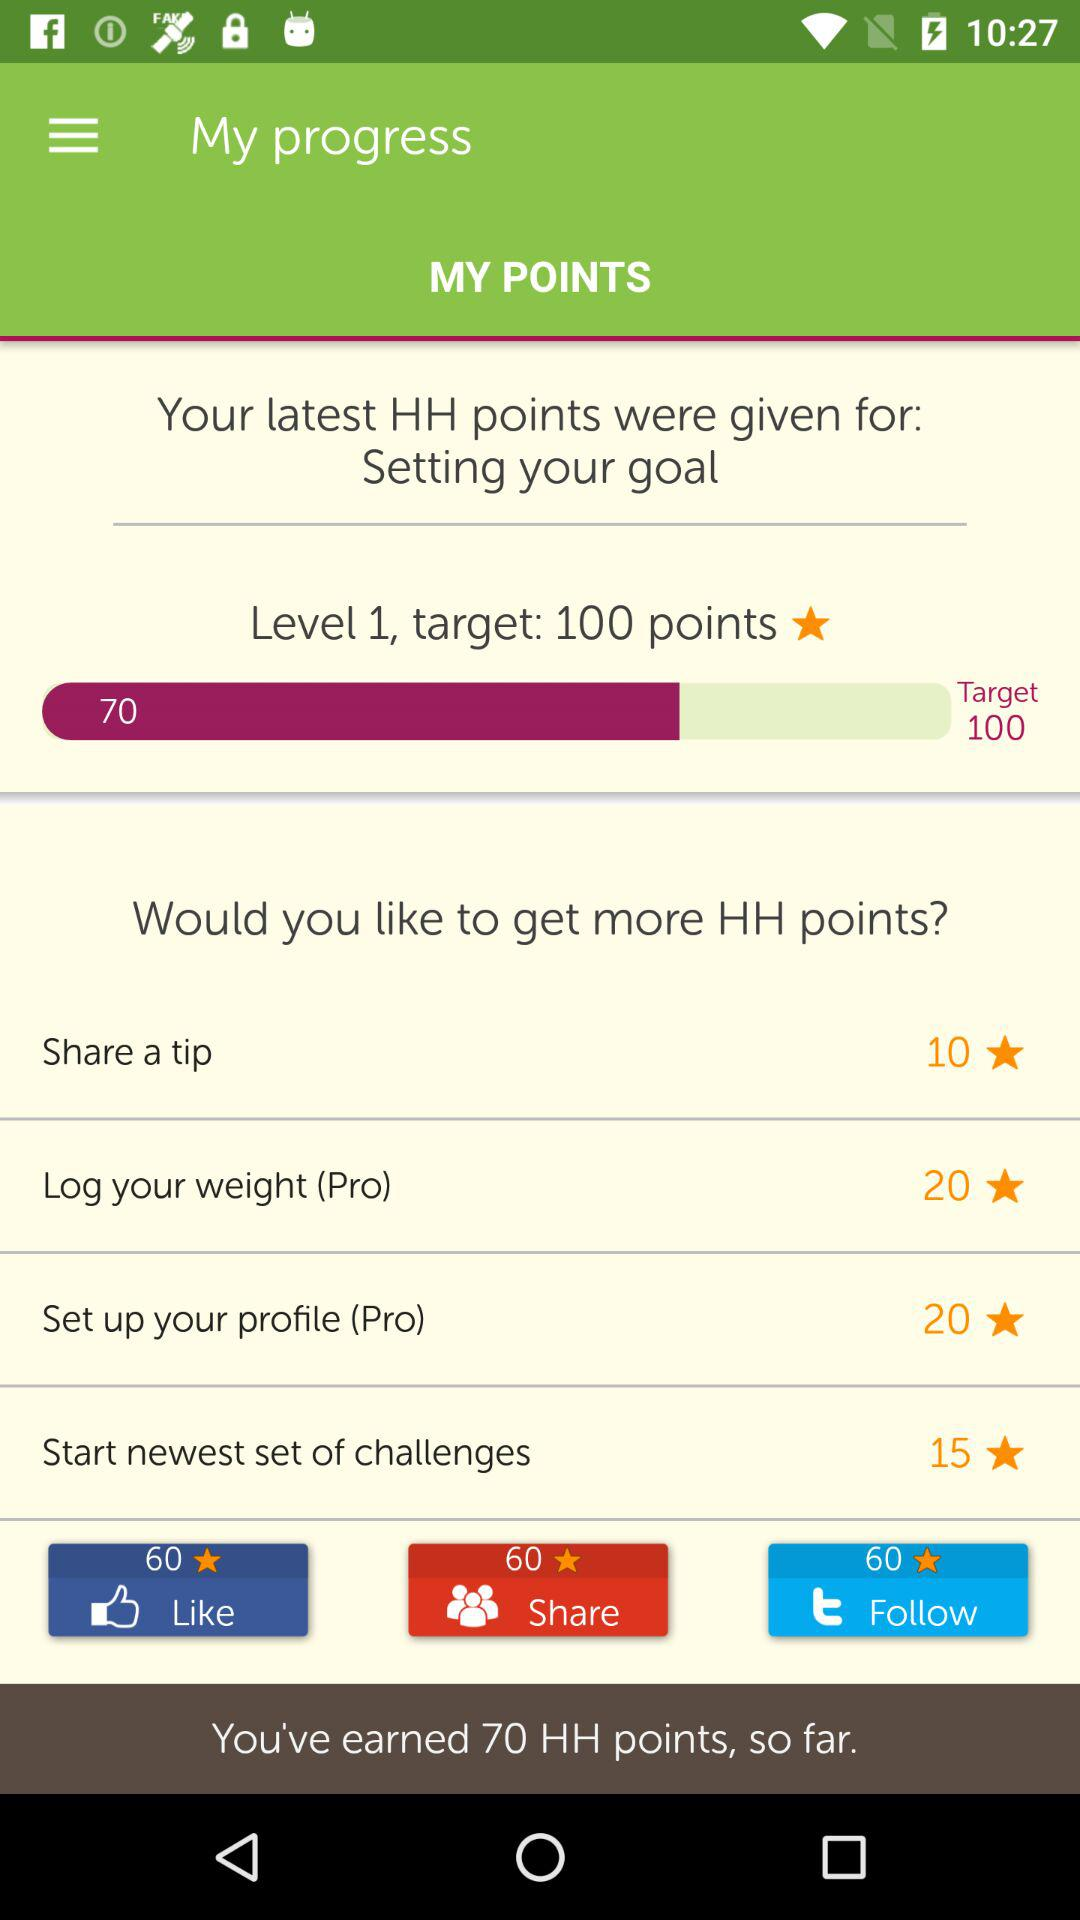What level is it? It is Level 1. 